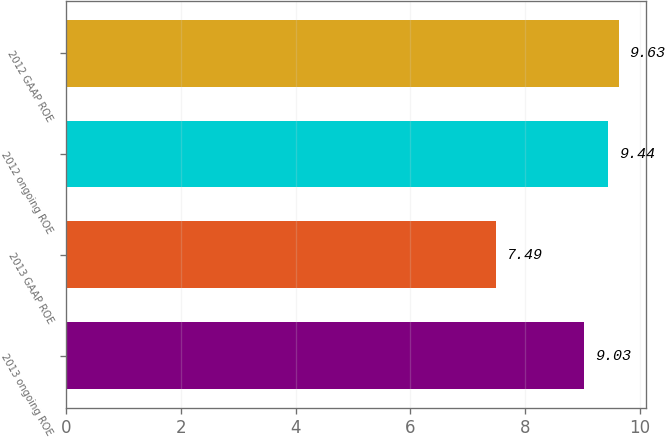Convert chart to OTSL. <chart><loc_0><loc_0><loc_500><loc_500><bar_chart><fcel>2013 ongoing ROE<fcel>2013 GAAP ROE<fcel>2012 ongoing ROE<fcel>2012 GAAP ROE<nl><fcel>9.03<fcel>7.49<fcel>9.44<fcel>9.63<nl></chart> 